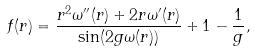<formula> <loc_0><loc_0><loc_500><loc_500>f ( r ) = \frac { r ^ { 2 } \omega ^ { \prime \prime } ( r ) + 2 r \omega ^ { \prime } ( r ) } { \sin ( 2 g \omega ( r ) ) } + 1 - \frac { 1 } { g } ,</formula> 